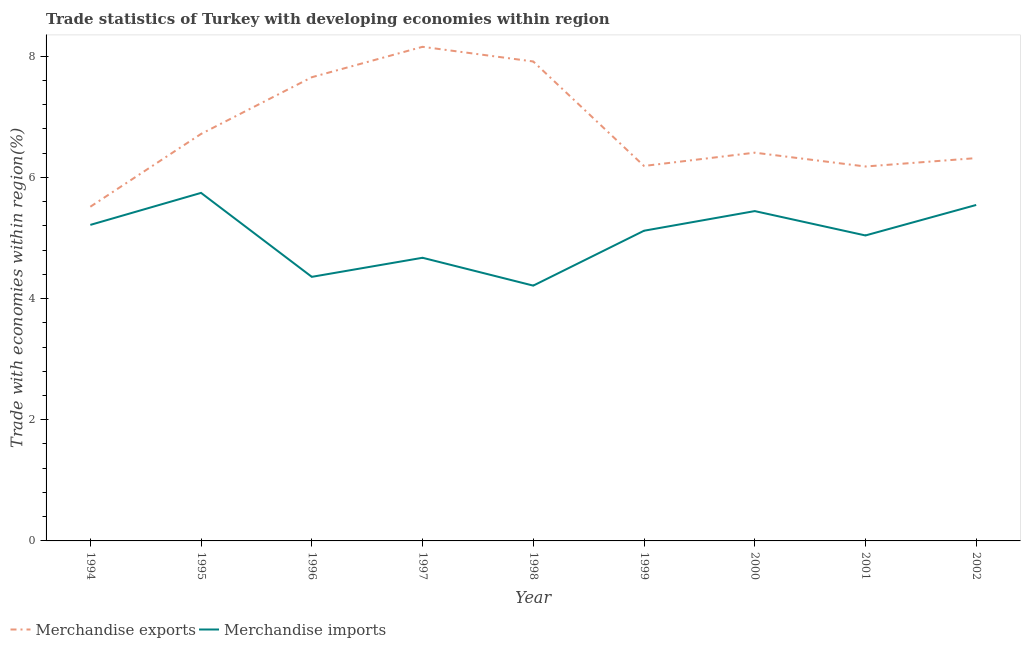How many different coloured lines are there?
Your response must be concise. 2. Is the number of lines equal to the number of legend labels?
Offer a terse response. Yes. What is the merchandise imports in 1995?
Your answer should be compact. 5.74. Across all years, what is the maximum merchandise imports?
Provide a succinct answer. 5.74. Across all years, what is the minimum merchandise imports?
Give a very brief answer. 4.21. In which year was the merchandise exports maximum?
Provide a short and direct response. 1997. What is the total merchandise imports in the graph?
Your answer should be compact. 45.35. What is the difference between the merchandise exports in 2000 and that in 2002?
Keep it short and to the point. 0.09. What is the difference between the merchandise exports in 1994 and the merchandise imports in 1995?
Provide a short and direct response. -0.23. What is the average merchandise imports per year?
Your answer should be compact. 5.04. In the year 2000, what is the difference between the merchandise imports and merchandise exports?
Provide a succinct answer. -0.96. In how many years, is the merchandise exports greater than 2 %?
Give a very brief answer. 9. What is the ratio of the merchandise exports in 1999 to that in 2002?
Give a very brief answer. 0.98. Is the merchandise imports in 1995 less than that in 2001?
Ensure brevity in your answer.  No. Is the difference between the merchandise imports in 1998 and 2002 greater than the difference between the merchandise exports in 1998 and 2002?
Your response must be concise. No. What is the difference between the highest and the second highest merchandise imports?
Give a very brief answer. 0.2. What is the difference between the highest and the lowest merchandise exports?
Provide a short and direct response. 2.64. Is the sum of the merchandise imports in 1995 and 1998 greater than the maximum merchandise exports across all years?
Make the answer very short. Yes. How many lines are there?
Keep it short and to the point. 2. How many years are there in the graph?
Give a very brief answer. 9. Are the values on the major ticks of Y-axis written in scientific E-notation?
Keep it short and to the point. No. Does the graph contain any zero values?
Ensure brevity in your answer.  No. Where does the legend appear in the graph?
Make the answer very short. Bottom left. What is the title of the graph?
Keep it short and to the point. Trade statistics of Turkey with developing economies within region. Does "GDP per capita" appear as one of the legend labels in the graph?
Your answer should be compact. No. What is the label or title of the X-axis?
Your answer should be compact. Year. What is the label or title of the Y-axis?
Keep it short and to the point. Trade with economies within region(%). What is the Trade with economies within region(%) of Merchandise exports in 1994?
Provide a succinct answer. 5.51. What is the Trade with economies within region(%) in Merchandise imports in 1994?
Your answer should be very brief. 5.22. What is the Trade with economies within region(%) in Merchandise exports in 1995?
Make the answer very short. 6.72. What is the Trade with economies within region(%) in Merchandise imports in 1995?
Your response must be concise. 5.74. What is the Trade with economies within region(%) in Merchandise exports in 1996?
Give a very brief answer. 7.65. What is the Trade with economies within region(%) in Merchandise imports in 1996?
Offer a very short reply. 4.36. What is the Trade with economies within region(%) in Merchandise exports in 1997?
Your answer should be very brief. 8.15. What is the Trade with economies within region(%) of Merchandise imports in 1997?
Offer a very short reply. 4.67. What is the Trade with economies within region(%) of Merchandise exports in 1998?
Offer a terse response. 7.91. What is the Trade with economies within region(%) of Merchandise imports in 1998?
Provide a succinct answer. 4.21. What is the Trade with economies within region(%) of Merchandise exports in 1999?
Keep it short and to the point. 6.19. What is the Trade with economies within region(%) of Merchandise imports in 1999?
Your answer should be compact. 5.12. What is the Trade with economies within region(%) in Merchandise exports in 2000?
Offer a terse response. 6.41. What is the Trade with economies within region(%) in Merchandise imports in 2000?
Your answer should be very brief. 5.44. What is the Trade with economies within region(%) of Merchandise exports in 2001?
Your response must be concise. 6.18. What is the Trade with economies within region(%) in Merchandise imports in 2001?
Your response must be concise. 5.04. What is the Trade with economies within region(%) of Merchandise exports in 2002?
Provide a short and direct response. 6.32. What is the Trade with economies within region(%) in Merchandise imports in 2002?
Ensure brevity in your answer.  5.54. Across all years, what is the maximum Trade with economies within region(%) of Merchandise exports?
Provide a short and direct response. 8.15. Across all years, what is the maximum Trade with economies within region(%) in Merchandise imports?
Give a very brief answer. 5.74. Across all years, what is the minimum Trade with economies within region(%) of Merchandise exports?
Provide a short and direct response. 5.51. Across all years, what is the minimum Trade with economies within region(%) in Merchandise imports?
Keep it short and to the point. 4.21. What is the total Trade with economies within region(%) in Merchandise exports in the graph?
Provide a short and direct response. 61.04. What is the total Trade with economies within region(%) in Merchandise imports in the graph?
Ensure brevity in your answer.  45.35. What is the difference between the Trade with economies within region(%) in Merchandise exports in 1994 and that in 1995?
Ensure brevity in your answer.  -1.2. What is the difference between the Trade with economies within region(%) in Merchandise imports in 1994 and that in 1995?
Keep it short and to the point. -0.53. What is the difference between the Trade with economies within region(%) in Merchandise exports in 1994 and that in 1996?
Provide a short and direct response. -2.14. What is the difference between the Trade with economies within region(%) in Merchandise imports in 1994 and that in 1996?
Keep it short and to the point. 0.86. What is the difference between the Trade with economies within region(%) in Merchandise exports in 1994 and that in 1997?
Keep it short and to the point. -2.64. What is the difference between the Trade with economies within region(%) of Merchandise imports in 1994 and that in 1997?
Your answer should be compact. 0.54. What is the difference between the Trade with economies within region(%) of Merchandise exports in 1994 and that in 1998?
Offer a terse response. -2.4. What is the difference between the Trade with economies within region(%) of Merchandise imports in 1994 and that in 1998?
Your answer should be compact. 1. What is the difference between the Trade with economies within region(%) in Merchandise exports in 1994 and that in 1999?
Keep it short and to the point. -0.67. What is the difference between the Trade with economies within region(%) of Merchandise imports in 1994 and that in 1999?
Provide a short and direct response. 0.1. What is the difference between the Trade with economies within region(%) in Merchandise exports in 1994 and that in 2000?
Offer a terse response. -0.89. What is the difference between the Trade with economies within region(%) in Merchandise imports in 1994 and that in 2000?
Provide a succinct answer. -0.23. What is the difference between the Trade with economies within region(%) of Merchandise exports in 1994 and that in 2001?
Offer a very short reply. -0.66. What is the difference between the Trade with economies within region(%) of Merchandise imports in 1994 and that in 2001?
Ensure brevity in your answer.  0.17. What is the difference between the Trade with economies within region(%) of Merchandise exports in 1994 and that in 2002?
Offer a terse response. -0.8. What is the difference between the Trade with economies within region(%) of Merchandise imports in 1994 and that in 2002?
Provide a short and direct response. -0.33. What is the difference between the Trade with economies within region(%) in Merchandise exports in 1995 and that in 1996?
Your answer should be compact. -0.94. What is the difference between the Trade with economies within region(%) in Merchandise imports in 1995 and that in 1996?
Your response must be concise. 1.39. What is the difference between the Trade with economies within region(%) in Merchandise exports in 1995 and that in 1997?
Offer a terse response. -1.44. What is the difference between the Trade with economies within region(%) of Merchandise imports in 1995 and that in 1997?
Offer a very short reply. 1.07. What is the difference between the Trade with economies within region(%) of Merchandise exports in 1995 and that in 1998?
Your response must be concise. -1.2. What is the difference between the Trade with economies within region(%) in Merchandise imports in 1995 and that in 1998?
Provide a short and direct response. 1.53. What is the difference between the Trade with economies within region(%) in Merchandise exports in 1995 and that in 1999?
Offer a terse response. 0.53. What is the difference between the Trade with economies within region(%) of Merchandise imports in 1995 and that in 1999?
Keep it short and to the point. 0.62. What is the difference between the Trade with economies within region(%) of Merchandise exports in 1995 and that in 2000?
Provide a short and direct response. 0.31. What is the difference between the Trade with economies within region(%) in Merchandise imports in 1995 and that in 2000?
Offer a very short reply. 0.3. What is the difference between the Trade with economies within region(%) of Merchandise exports in 1995 and that in 2001?
Provide a succinct answer. 0.54. What is the difference between the Trade with economies within region(%) of Merchandise imports in 1995 and that in 2001?
Provide a succinct answer. 0.7. What is the difference between the Trade with economies within region(%) of Merchandise exports in 1995 and that in 2002?
Your answer should be very brief. 0.4. What is the difference between the Trade with economies within region(%) of Merchandise imports in 1995 and that in 2002?
Your answer should be very brief. 0.2. What is the difference between the Trade with economies within region(%) in Merchandise exports in 1996 and that in 1997?
Provide a short and direct response. -0.5. What is the difference between the Trade with economies within region(%) of Merchandise imports in 1996 and that in 1997?
Provide a succinct answer. -0.31. What is the difference between the Trade with economies within region(%) in Merchandise exports in 1996 and that in 1998?
Your answer should be compact. -0.26. What is the difference between the Trade with economies within region(%) of Merchandise imports in 1996 and that in 1998?
Your response must be concise. 0.14. What is the difference between the Trade with economies within region(%) in Merchandise exports in 1996 and that in 1999?
Offer a very short reply. 1.46. What is the difference between the Trade with economies within region(%) of Merchandise imports in 1996 and that in 1999?
Offer a very short reply. -0.76. What is the difference between the Trade with economies within region(%) of Merchandise exports in 1996 and that in 2000?
Offer a very short reply. 1.25. What is the difference between the Trade with economies within region(%) of Merchandise imports in 1996 and that in 2000?
Your answer should be very brief. -1.09. What is the difference between the Trade with economies within region(%) in Merchandise exports in 1996 and that in 2001?
Your answer should be very brief. 1.47. What is the difference between the Trade with economies within region(%) of Merchandise imports in 1996 and that in 2001?
Offer a very short reply. -0.68. What is the difference between the Trade with economies within region(%) in Merchandise exports in 1996 and that in 2002?
Your answer should be compact. 1.33. What is the difference between the Trade with economies within region(%) of Merchandise imports in 1996 and that in 2002?
Offer a very short reply. -1.19. What is the difference between the Trade with economies within region(%) in Merchandise exports in 1997 and that in 1998?
Your response must be concise. 0.24. What is the difference between the Trade with economies within region(%) of Merchandise imports in 1997 and that in 1998?
Ensure brevity in your answer.  0.46. What is the difference between the Trade with economies within region(%) in Merchandise exports in 1997 and that in 1999?
Offer a terse response. 1.97. What is the difference between the Trade with economies within region(%) of Merchandise imports in 1997 and that in 1999?
Offer a very short reply. -0.45. What is the difference between the Trade with economies within region(%) in Merchandise exports in 1997 and that in 2000?
Provide a short and direct response. 1.75. What is the difference between the Trade with economies within region(%) of Merchandise imports in 1997 and that in 2000?
Your response must be concise. -0.77. What is the difference between the Trade with economies within region(%) in Merchandise exports in 1997 and that in 2001?
Make the answer very short. 1.98. What is the difference between the Trade with economies within region(%) of Merchandise imports in 1997 and that in 2001?
Keep it short and to the point. -0.37. What is the difference between the Trade with economies within region(%) in Merchandise exports in 1997 and that in 2002?
Provide a short and direct response. 1.84. What is the difference between the Trade with economies within region(%) in Merchandise imports in 1997 and that in 2002?
Keep it short and to the point. -0.87. What is the difference between the Trade with economies within region(%) of Merchandise exports in 1998 and that in 1999?
Make the answer very short. 1.72. What is the difference between the Trade with economies within region(%) of Merchandise imports in 1998 and that in 1999?
Make the answer very short. -0.91. What is the difference between the Trade with economies within region(%) in Merchandise exports in 1998 and that in 2000?
Provide a succinct answer. 1.5. What is the difference between the Trade with economies within region(%) in Merchandise imports in 1998 and that in 2000?
Offer a terse response. -1.23. What is the difference between the Trade with economies within region(%) in Merchandise exports in 1998 and that in 2001?
Your response must be concise. 1.73. What is the difference between the Trade with economies within region(%) of Merchandise imports in 1998 and that in 2001?
Your answer should be very brief. -0.83. What is the difference between the Trade with economies within region(%) in Merchandise exports in 1998 and that in 2002?
Make the answer very short. 1.59. What is the difference between the Trade with economies within region(%) in Merchandise imports in 1998 and that in 2002?
Your answer should be compact. -1.33. What is the difference between the Trade with economies within region(%) of Merchandise exports in 1999 and that in 2000?
Make the answer very short. -0.22. What is the difference between the Trade with economies within region(%) in Merchandise imports in 1999 and that in 2000?
Make the answer very short. -0.32. What is the difference between the Trade with economies within region(%) of Merchandise exports in 1999 and that in 2001?
Ensure brevity in your answer.  0.01. What is the difference between the Trade with economies within region(%) of Merchandise imports in 1999 and that in 2001?
Ensure brevity in your answer.  0.08. What is the difference between the Trade with economies within region(%) of Merchandise exports in 1999 and that in 2002?
Your response must be concise. -0.13. What is the difference between the Trade with economies within region(%) in Merchandise imports in 1999 and that in 2002?
Your answer should be compact. -0.43. What is the difference between the Trade with economies within region(%) of Merchandise exports in 2000 and that in 2001?
Offer a very short reply. 0.23. What is the difference between the Trade with economies within region(%) of Merchandise imports in 2000 and that in 2001?
Your response must be concise. 0.4. What is the difference between the Trade with economies within region(%) of Merchandise exports in 2000 and that in 2002?
Ensure brevity in your answer.  0.09. What is the difference between the Trade with economies within region(%) in Merchandise imports in 2000 and that in 2002?
Offer a terse response. -0.1. What is the difference between the Trade with economies within region(%) of Merchandise exports in 2001 and that in 2002?
Provide a succinct answer. -0.14. What is the difference between the Trade with economies within region(%) in Merchandise imports in 2001 and that in 2002?
Make the answer very short. -0.5. What is the difference between the Trade with economies within region(%) in Merchandise exports in 1994 and the Trade with economies within region(%) in Merchandise imports in 1995?
Give a very brief answer. -0.23. What is the difference between the Trade with economies within region(%) of Merchandise exports in 1994 and the Trade with economies within region(%) of Merchandise imports in 1996?
Offer a terse response. 1.16. What is the difference between the Trade with economies within region(%) in Merchandise exports in 1994 and the Trade with economies within region(%) in Merchandise imports in 1997?
Your response must be concise. 0.84. What is the difference between the Trade with economies within region(%) of Merchandise exports in 1994 and the Trade with economies within region(%) of Merchandise imports in 1998?
Make the answer very short. 1.3. What is the difference between the Trade with economies within region(%) in Merchandise exports in 1994 and the Trade with economies within region(%) in Merchandise imports in 1999?
Provide a succinct answer. 0.4. What is the difference between the Trade with economies within region(%) in Merchandise exports in 1994 and the Trade with economies within region(%) in Merchandise imports in 2000?
Your answer should be compact. 0.07. What is the difference between the Trade with economies within region(%) of Merchandise exports in 1994 and the Trade with economies within region(%) of Merchandise imports in 2001?
Your answer should be very brief. 0.47. What is the difference between the Trade with economies within region(%) in Merchandise exports in 1994 and the Trade with economies within region(%) in Merchandise imports in 2002?
Your answer should be very brief. -0.03. What is the difference between the Trade with economies within region(%) of Merchandise exports in 1995 and the Trade with economies within region(%) of Merchandise imports in 1996?
Your answer should be very brief. 2.36. What is the difference between the Trade with economies within region(%) in Merchandise exports in 1995 and the Trade with economies within region(%) in Merchandise imports in 1997?
Offer a terse response. 2.04. What is the difference between the Trade with economies within region(%) of Merchandise exports in 1995 and the Trade with economies within region(%) of Merchandise imports in 1998?
Keep it short and to the point. 2.5. What is the difference between the Trade with economies within region(%) of Merchandise exports in 1995 and the Trade with economies within region(%) of Merchandise imports in 1999?
Keep it short and to the point. 1.6. What is the difference between the Trade with economies within region(%) of Merchandise exports in 1995 and the Trade with economies within region(%) of Merchandise imports in 2000?
Provide a succinct answer. 1.27. What is the difference between the Trade with economies within region(%) of Merchandise exports in 1995 and the Trade with economies within region(%) of Merchandise imports in 2001?
Provide a succinct answer. 1.68. What is the difference between the Trade with economies within region(%) of Merchandise exports in 1995 and the Trade with economies within region(%) of Merchandise imports in 2002?
Offer a terse response. 1.17. What is the difference between the Trade with economies within region(%) in Merchandise exports in 1996 and the Trade with economies within region(%) in Merchandise imports in 1997?
Ensure brevity in your answer.  2.98. What is the difference between the Trade with economies within region(%) in Merchandise exports in 1996 and the Trade with economies within region(%) in Merchandise imports in 1998?
Your response must be concise. 3.44. What is the difference between the Trade with economies within region(%) of Merchandise exports in 1996 and the Trade with economies within region(%) of Merchandise imports in 1999?
Your answer should be compact. 2.53. What is the difference between the Trade with economies within region(%) in Merchandise exports in 1996 and the Trade with economies within region(%) in Merchandise imports in 2000?
Your answer should be very brief. 2.21. What is the difference between the Trade with economies within region(%) in Merchandise exports in 1996 and the Trade with economies within region(%) in Merchandise imports in 2001?
Offer a very short reply. 2.61. What is the difference between the Trade with economies within region(%) in Merchandise exports in 1996 and the Trade with economies within region(%) in Merchandise imports in 2002?
Offer a very short reply. 2.11. What is the difference between the Trade with economies within region(%) in Merchandise exports in 1997 and the Trade with economies within region(%) in Merchandise imports in 1998?
Make the answer very short. 3.94. What is the difference between the Trade with economies within region(%) in Merchandise exports in 1997 and the Trade with economies within region(%) in Merchandise imports in 1999?
Offer a very short reply. 3.04. What is the difference between the Trade with economies within region(%) of Merchandise exports in 1997 and the Trade with economies within region(%) of Merchandise imports in 2000?
Offer a terse response. 2.71. What is the difference between the Trade with economies within region(%) in Merchandise exports in 1997 and the Trade with economies within region(%) in Merchandise imports in 2001?
Make the answer very short. 3.11. What is the difference between the Trade with economies within region(%) of Merchandise exports in 1997 and the Trade with economies within region(%) of Merchandise imports in 2002?
Give a very brief answer. 2.61. What is the difference between the Trade with economies within region(%) in Merchandise exports in 1998 and the Trade with economies within region(%) in Merchandise imports in 1999?
Your response must be concise. 2.79. What is the difference between the Trade with economies within region(%) in Merchandise exports in 1998 and the Trade with economies within region(%) in Merchandise imports in 2000?
Offer a very short reply. 2.47. What is the difference between the Trade with economies within region(%) of Merchandise exports in 1998 and the Trade with economies within region(%) of Merchandise imports in 2001?
Your answer should be very brief. 2.87. What is the difference between the Trade with economies within region(%) of Merchandise exports in 1998 and the Trade with economies within region(%) of Merchandise imports in 2002?
Ensure brevity in your answer.  2.37. What is the difference between the Trade with economies within region(%) of Merchandise exports in 1999 and the Trade with economies within region(%) of Merchandise imports in 2000?
Give a very brief answer. 0.74. What is the difference between the Trade with economies within region(%) of Merchandise exports in 1999 and the Trade with economies within region(%) of Merchandise imports in 2001?
Offer a terse response. 1.15. What is the difference between the Trade with economies within region(%) of Merchandise exports in 1999 and the Trade with economies within region(%) of Merchandise imports in 2002?
Offer a terse response. 0.64. What is the difference between the Trade with economies within region(%) of Merchandise exports in 2000 and the Trade with economies within region(%) of Merchandise imports in 2001?
Provide a short and direct response. 1.37. What is the difference between the Trade with economies within region(%) of Merchandise exports in 2000 and the Trade with economies within region(%) of Merchandise imports in 2002?
Your answer should be very brief. 0.86. What is the difference between the Trade with economies within region(%) of Merchandise exports in 2001 and the Trade with economies within region(%) of Merchandise imports in 2002?
Offer a terse response. 0.63. What is the average Trade with economies within region(%) of Merchandise exports per year?
Make the answer very short. 6.78. What is the average Trade with economies within region(%) of Merchandise imports per year?
Provide a succinct answer. 5.04. In the year 1994, what is the difference between the Trade with economies within region(%) of Merchandise exports and Trade with economies within region(%) of Merchandise imports?
Offer a terse response. 0.3. In the year 1995, what is the difference between the Trade with economies within region(%) in Merchandise exports and Trade with economies within region(%) in Merchandise imports?
Your answer should be very brief. 0.97. In the year 1996, what is the difference between the Trade with economies within region(%) of Merchandise exports and Trade with economies within region(%) of Merchandise imports?
Provide a succinct answer. 3.29. In the year 1997, what is the difference between the Trade with economies within region(%) of Merchandise exports and Trade with economies within region(%) of Merchandise imports?
Your response must be concise. 3.48. In the year 1998, what is the difference between the Trade with economies within region(%) of Merchandise exports and Trade with economies within region(%) of Merchandise imports?
Offer a very short reply. 3.7. In the year 1999, what is the difference between the Trade with economies within region(%) of Merchandise exports and Trade with economies within region(%) of Merchandise imports?
Provide a succinct answer. 1.07. In the year 2001, what is the difference between the Trade with economies within region(%) of Merchandise exports and Trade with economies within region(%) of Merchandise imports?
Provide a succinct answer. 1.14. In the year 2002, what is the difference between the Trade with economies within region(%) of Merchandise exports and Trade with economies within region(%) of Merchandise imports?
Ensure brevity in your answer.  0.77. What is the ratio of the Trade with economies within region(%) of Merchandise exports in 1994 to that in 1995?
Provide a short and direct response. 0.82. What is the ratio of the Trade with economies within region(%) of Merchandise imports in 1994 to that in 1995?
Your answer should be compact. 0.91. What is the ratio of the Trade with economies within region(%) of Merchandise exports in 1994 to that in 1996?
Offer a terse response. 0.72. What is the ratio of the Trade with economies within region(%) of Merchandise imports in 1994 to that in 1996?
Ensure brevity in your answer.  1.2. What is the ratio of the Trade with economies within region(%) of Merchandise exports in 1994 to that in 1997?
Your answer should be very brief. 0.68. What is the ratio of the Trade with economies within region(%) of Merchandise imports in 1994 to that in 1997?
Offer a very short reply. 1.12. What is the ratio of the Trade with economies within region(%) in Merchandise exports in 1994 to that in 1998?
Your answer should be compact. 0.7. What is the ratio of the Trade with economies within region(%) in Merchandise imports in 1994 to that in 1998?
Give a very brief answer. 1.24. What is the ratio of the Trade with economies within region(%) of Merchandise exports in 1994 to that in 1999?
Ensure brevity in your answer.  0.89. What is the ratio of the Trade with economies within region(%) of Merchandise imports in 1994 to that in 1999?
Your response must be concise. 1.02. What is the ratio of the Trade with economies within region(%) of Merchandise exports in 1994 to that in 2000?
Your response must be concise. 0.86. What is the ratio of the Trade with economies within region(%) of Merchandise imports in 1994 to that in 2000?
Keep it short and to the point. 0.96. What is the ratio of the Trade with economies within region(%) in Merchandise exports in 1994 to that in 2001?
Offer a very short reply. 0.89. What is the ratio of the Trade with economies within region(%) in Merchandise imports in 1994 to that in 2001?
Give a very brief answer. 1.03. What is the ratio of the Trade with economies within region(%) of Merchandise exports in 1994 to that in 2002?
Provide a succinct answer. 0.87. What is the ratio of the Trade with economies within region(%) in Merchandise imports in 1994 to that in 2002?
Give a very brief answer. 0.94. What is the ratio of the Trade with economies within region(%) in Merchandise exports in 1995 to that in 1996?
Offer a very short reply. 0.88. What is the ratio of the Trade with economies within region(%) in Merchandise imports in 1995 to that in 1996?
Keep it short and to the point. 1.32. What is the ratio of the Trade with economies within region(%) in Merchandise exports in 1995 to that in 1997?
Give a very brief answer. 0.82. What is the ratio of the Trade with economies within region(%) in Merchandise imports in 1995 to that in 1997?
Offer a very short reply. 1.23. What is the ratio of the Trade with economies within region(%) in Merchandise exports in 1995 to that in 1998?
Make the answer very short. 0.85. What is the ratio of the Trade with economies within region(%) in Merchandise imports in 1995 to that in 1998?
Your answer should be compact. 1.36. What is the ratio of the Trade with economies within region(%) in Merchandise exports in 1995 to that in 1999?
Your answer should be very brief. 1.09. What is the ratio of the Trade with economies within region(%) of Merchandise imports in 1995 to that in 1999?
Give a very brief answer. 1.12. What is the ratio of the Trade with economies within region(%) of Merchandise exports in 1995 to that in 2000?
Keep it short and to the point. 1.05. What is the ratio of the Trade with economies within region(%) of Merchandise imports in 1995 to that in 2000?
Your answer should be compact. 1.06. What is the ratio of the Trade with economies within region(%) in Merchandise exports in 1995 to that in 2001?
Provide a succinct answer. 1.09. What is the ratio of the Trade with economies within region(%) of Merchandise imports in 1995 to that in 2001?
Give a very brief answer. 1.14. What is the ratio of the Trade with economies within region(%) in Merchandise exports in 1995 to that in 2002?
Give a very brief answer. 1.06. What is the ratio of the Trade with economies within region(%) of Merchandise imports in 1995 to that in 2002?
Provide a succinct answer. 1.04. What is the ratio of the Trade with economies within region(%) in Merchandise exports in 1996 to that in 1997?
Provide a short and direct response. 0.94. What is the ratio of the Trade with economies within region(%) in Merchandise imports in 1996 to that in 1997?
Your answer should be compact. 0.93. What is the ratio of the Trade with economies within region(%) in Merchandise exports in 1996 to that in 1998?
Give a very brief answer. 0.97. What is the ratio of the Trade with economies within region(%) in Merchandise imports in 1996 to that in 1998?
Ensure brevity in your answer.  1.03. What is the ratio of the Trade with economies within region(%) of Merchandise exports in 1996 to that in 1999?
Make the answer very short. 1.24. What is the ratio of the Trade with economies within region(%) of Merchandise imports in 1996 to that in 1999?
Your answer should be compact. 0.85. What is the ratio of the Trade with economies within region(%) in Merchandise exports in 1996 to that in 2000?
Your answer should be very brief. 1.19. What is the ratio of the Trade with economies within region(%) of Merchandise imports in 1996 to that in 2000?
Your response must be concise. 0.8. What is the ratio of the Trade with economies within region(%) of Merchandise exports in 1996 to that in 2001?
Provide a short and direct response. 1.24. What is the ratio of the Trade with economies within region(%) in Merchandise imports in 1996 to that in 2001?
Give a very brief answer. 0.86. What is the ratio of the Trade with economies within region(%) in Merchandise exports in 1996 to that in 2002?
Offer a terse response. 1.21. What is the ratio of the Trade with economies within region(%) of Merchandise imports in 1996 to that in 2002?
Provide a short and direct response. 0.79. What is the ratio of the Trade with economies within region(%) in Merchandise exports in 1997 to that in 1998?
Give a very brief answer. 1.03. What is the ratio of the Trade with economies within region(%) of Merchandise imports in 1997 to that in 1998?
Make the answer very short. 1.11. What is the ratio of the Trade with economies within region(%) of Merchandise exports in 1997 to that in 1999?
Give a very brief answer. 1.32. What is the ratio of the Trade with economies within region(%) in Merchandise imports in 1997 to that in 1999?
Your response must be concise. 0.91. What is the ratio of the Trade with economies within region(%) in Merchandise exports in 1997 to that in 2000?
Provide a short and direct response. 1.27. What is the ratio of the Trade with economies within region(%) of Merchandise imports in 1997 to that in 2000?
Give a very brief answer. 0.86. What is the ratio of the Trade with economies within region(%) of Merchandise exports in 1997 to that in 2001?
Provide a succinct answer. 1.32. What is the ratio of the Trade with economies within region(%) of Merchandise imports in 1997 to that in 2001?
Ensure brevity in your answer.  0.93. What is the ratio of the Trade with economies within region(%) in Merchandise exports in 1997 to that in 2002?
Your response must be concise. 1.29. What is the ratio of the Trade with economies within region(%) in Merchandise imports in 1997 to that in 2002?
Give a very brief answer. 0.84. What is the ratio of the Trade with economies within region(%) of Merchandise exports in 1998 to that in 1999?
Provide a short and direct response. 1.28. What is the ratio of the Trade with economies within region(%) in Merchandise imports in 1998 to that in 1999?
Ensure brevity in your answer.  0.82. What is the ratio of the Trade with economies within region(%) in Merchandise exports in 1998 to that in 2000?
Provide a short and direct response. 1.23. What is the ratio of the Trade with economies within region(%) in Merchandise imports in 1998 to that in 2000?
Your response must be concise. 0.77. What is the ratio of the Trade with economies within region(%) of Merchandise exports in 1998 to that in 2001?
Provide a short and direct response. 1.28. What is the ratio of the Trade with economies within region(%) in Merchandise imports in 1998 to that in 2001?
Your answer should be compact. 0.84. What is the ratio of the Trade with economies within region(%) in Merchandise exports in 1998 to that in 2002?
Your answer should be compact. 1.25. What is the ratio of the Trade with economies within region(%) of Merchandise imports in 1998 to that in 2002?
Ensure brevity in your answer.  0.76. What is the ratio of the Trade with economies within region(%) in Merchandise exports in 1999 to that in 2000?
Provide a succinct answer. 0.97. What is the ratio of the Trade with economies within region(%) of Merchandise imports in 1999 to that in 2000?
Make the answer very short. 0.94. What is the ratio of the Trade with economies within region(%) of Merchandise imports in 1999 to that in 2001?
Your answer should be compact. 1.02. What is the ratio of the Trade with economies within region(%) of Merchandise exports in 1999 to that in 2002?
Ensure brevity in your answer.  0.98. What is the ratio of the Trade with economies within region(%) of Merchandise imports in 1999 to that in 2002?
Provide a succinct answer. 0.92. What is the ratio of the Trade with economies within region(%) of Merchandise exports in 2000 to that in 2001?
Offer a very short reply. 1.04. What is the ratio of the Trade with economies within region(%) in Merchandise imports in 2000 to that in 2001?
Ensure brevity in your answer.  1.08. What is the ratio of the Trade with economies within region(%) of Merchandise exports in 2000 to that in 2002?
Provide a succinct answer. 1.01. What is the ratio of the Trade with economies within region(%) in Merchandise imports in 2000 to that in 2002?
Make the answer very short. 0.98. What is the ratio of the Trade with economies within region(%) of Merchandise exports in 2001 to that in 2002?
Your response must be concise. 0.98. What is the ratio of the Trade with economies within region(%) of Merchandise imports in 2001 to that in 2002?
Your answer should be very brief. 0.91. What is the difference between the highest and the second highest Trade with economies within region(%) of Merchandise exports?
Your answer should be compact. 0.24. What is the difference between the highest and the second highest Trade with economies within region(%) of Merchandise imports?
Provide a short and direct response. 0.2. What is the difference between the highest and the lowest Trade with economies within region(%) of Merchandise exports?
Your answer should be very brief. 2.64. What is the difference between the highest and the lowest Trade with economies within region(%) in Merchandise imports?
Your answer should be compact. 1.53. 